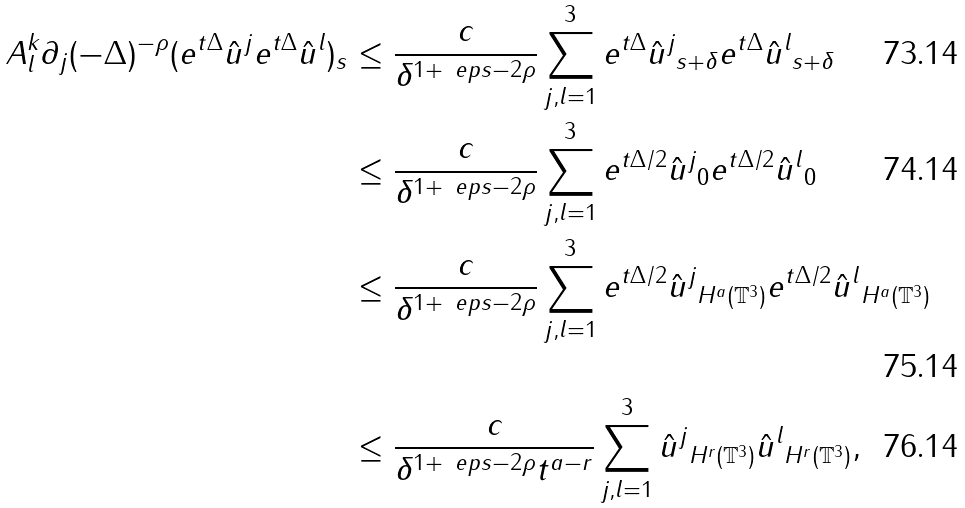<formula> <loc_0><loc_0><loc_500><loc_500>\| A _ { l } ^ { k } \partial _ { j } ( - \Delta ) ^ { - \rho } ( e ^ { t \Delta } \hat { u } ^ { j } e ^ { t \Delta } \hat { u } ^ { l } ) \| _ { s } & \leq \frac { c } { \delta ^ { 1 + \ e p s - 2 \rho } } \sum _ { j , l = 1 } ^ { 3 } \| e ^ { t \Delta } \hat { u } ^ { j } \| _ { s + \delta } \| e ^ { t \Delta } \hat { u } ^ { l } \| _ { s + \delta } \\ & \leq \frac { c } { \delta ^ { 1 + \ e p s - 2 \rho } } \sum _ { j , l = 1 } ^ { 3 } \| e ^ { t \Delta / 2 } \hat { u } ^ { j } \| _ { 0 } \| e ^ { t \Delta / 2 } \hat { u } ^ { l } \| _ { 0 } \\ & \leq \frac { c } { \delta ^ { 1 + \ e p s - 2 \rho } } \sum _ { j , l = 1 } ^ { 3 } \| e ^ { t \Delta / 2 } \hat { u } ^ { j } \| _ { H ^ { a } ( \mathbb { T } ^ { 3 } ) } \| e ^ { t \Delta / 2 } \hat { u } ^ { l } \| _ { H ^ { a } ( \mathbb { T } ^ { 3 } ) } \\ & \leq \frac { c } { \delta ^ { 1 + \ e p s - 2 \rho } t ^ { a - r } } \sum _ { j , l = 1 } ^ { 3 } \| \hat { u } ^ { j } \| _ { H ^ { r } ( \mathbb { T } ^ { 3 } ) } \| \hat { u } ^ { l } \| _ { H ^ { r } ( \mathbb { T } ^ { 3 } ) } ,</formula> 